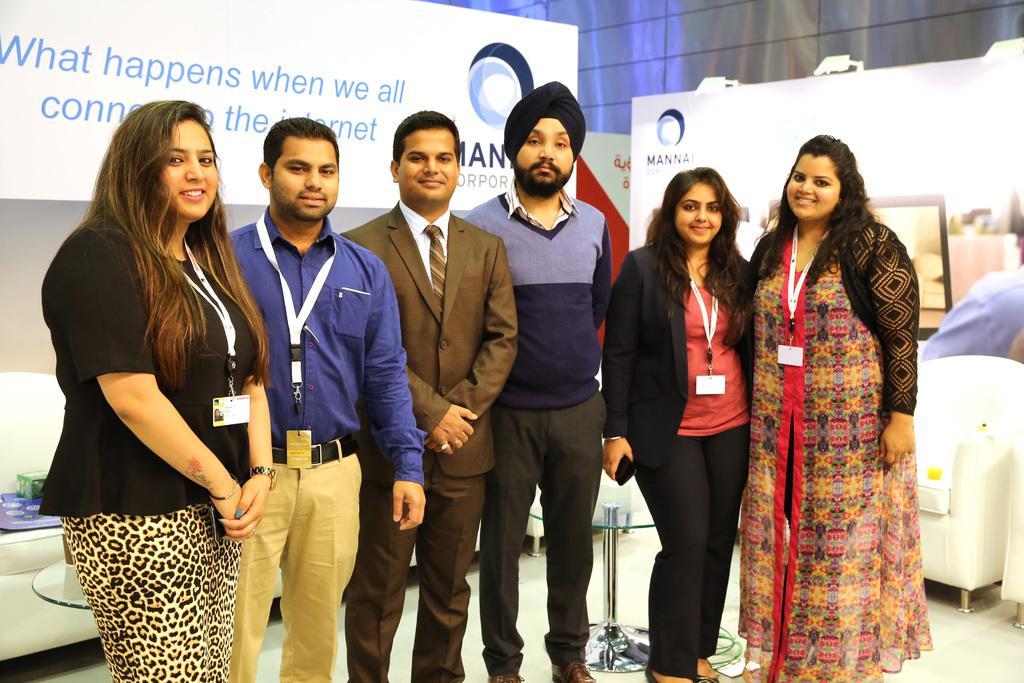Can you describe this image briefly? This image is taken indoors. At the bottom of the image there is a floor. In the background there are a few boards with text on them and there are a few couches on the floor and there is a table. In the middle of the image three men and three women are standing on the floor and they are with smiling faces. 